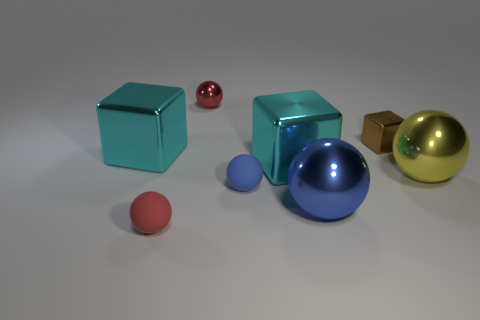Subtract all yellow spheres. How many spheres are left? 4 Subtract all yellow spheres. How many spheres are left? 4 Subtract all cyan balls. Subtract all brown cylinders. How many balls are left? 5 Add 1 big cyan objects. How many objects exist? 9 Subtract all balls. How many objects are left? 3 Add 2 big blue metallic things. How many big blue metallic things are left? 3 Add 7 tiny shiny objects. How many tiny shiny objects exist? 9 Subtract 0 blue cylinders. How many objects are left? 8 Subtract all tiny brown blocks. Subtract all green rubber balls. How many objects are left? 7 